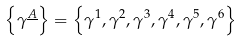Convert formula to latex. <formula><loc_0><loc_0><loc_500><loc_500>\left \{ \gamma ^ { \underline { A } } \right \} = \left \{ \gamma ^ { 1 } , \gamma ^ { 2 } , \gamma ^ { 3 } , \gamma ^ { 4 } , \gamma ^ { 5 } , \gamma ^ { 6 } \right \}</formula> 